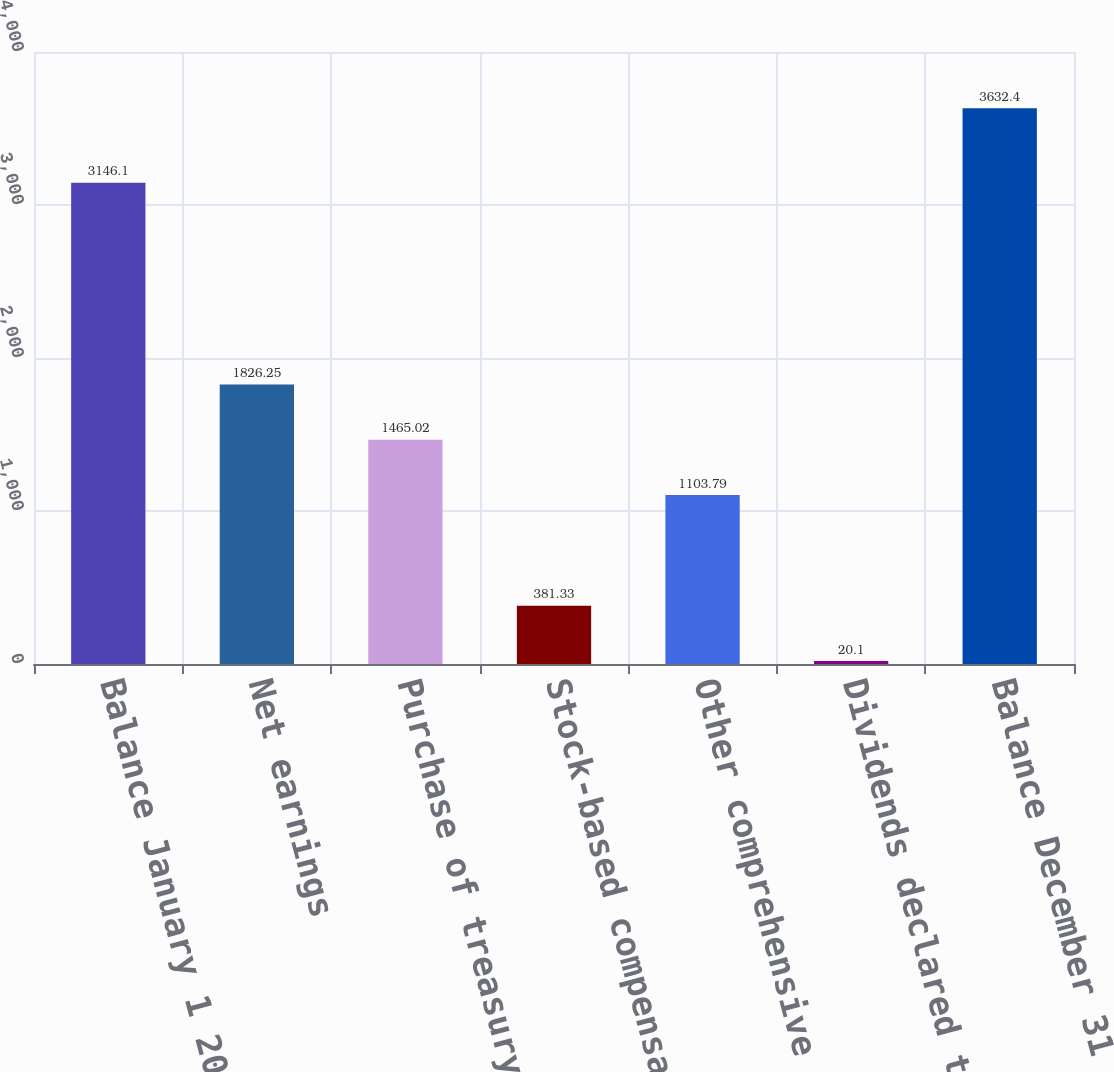Convert chart. <chart><loc_0><loc_0><loc_500><loc_500><bar_chart><fcel>Balance January 1 2013<fcel>Net earnings<fcel>Purchase of treasury stock<fcel>Stock-based compensation<fcel>Other comprehensive income<fcel>Dividends declared to<fcel>Balance December 31 2013<nl><fcel>3146.1<fcel>1826.25<fcel>1465.02<fcel>381.33<fcel>1103.79<fcel>20.1<fcel>3632.4<nl></chart> 